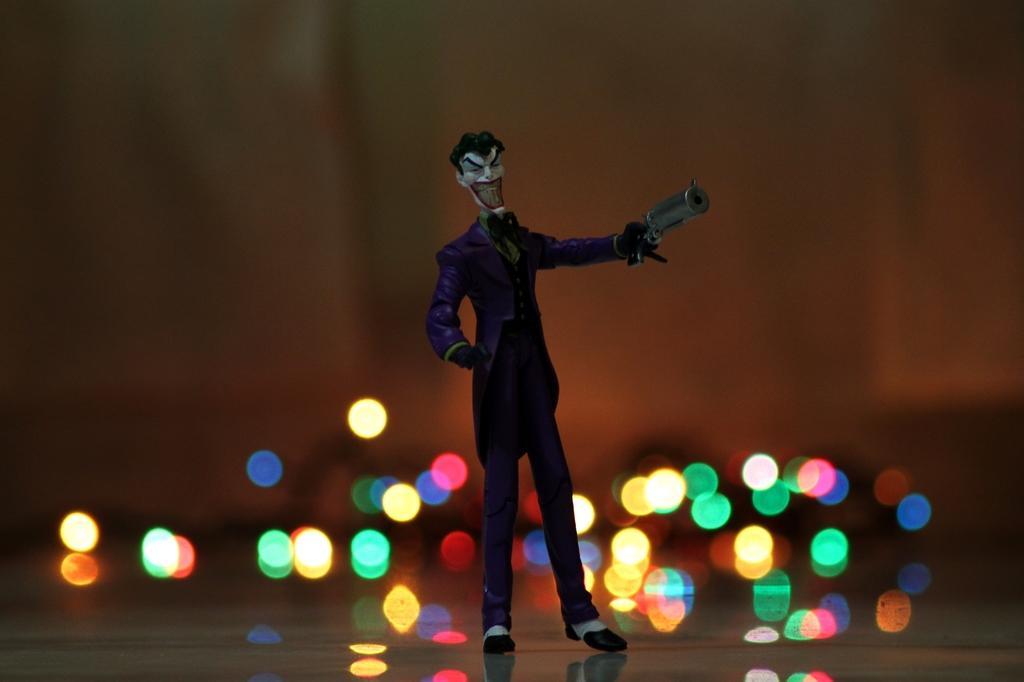Could you give a brief overview of what you see in this image? In this picture, it seems like a toy and light in the foreground. 